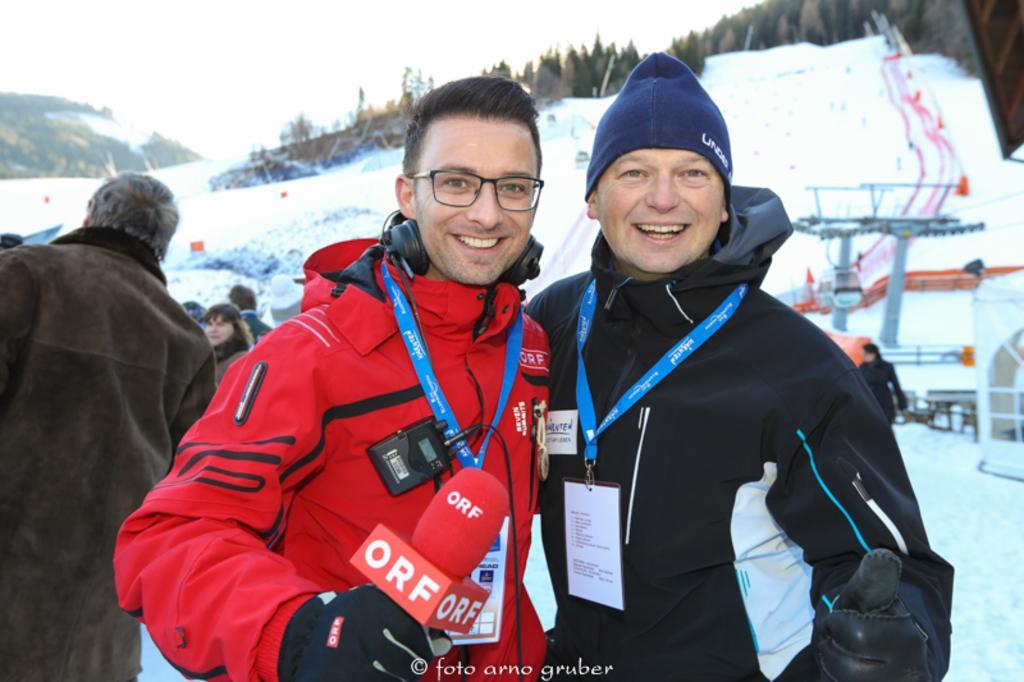Please provide a concise description of this image. In this image I can see group of people standing, in front the person is wearing red color jacket and the person at right is wearing black color jacket. Background I can see the snow in white color, trees in green color and the sky is in white color. 